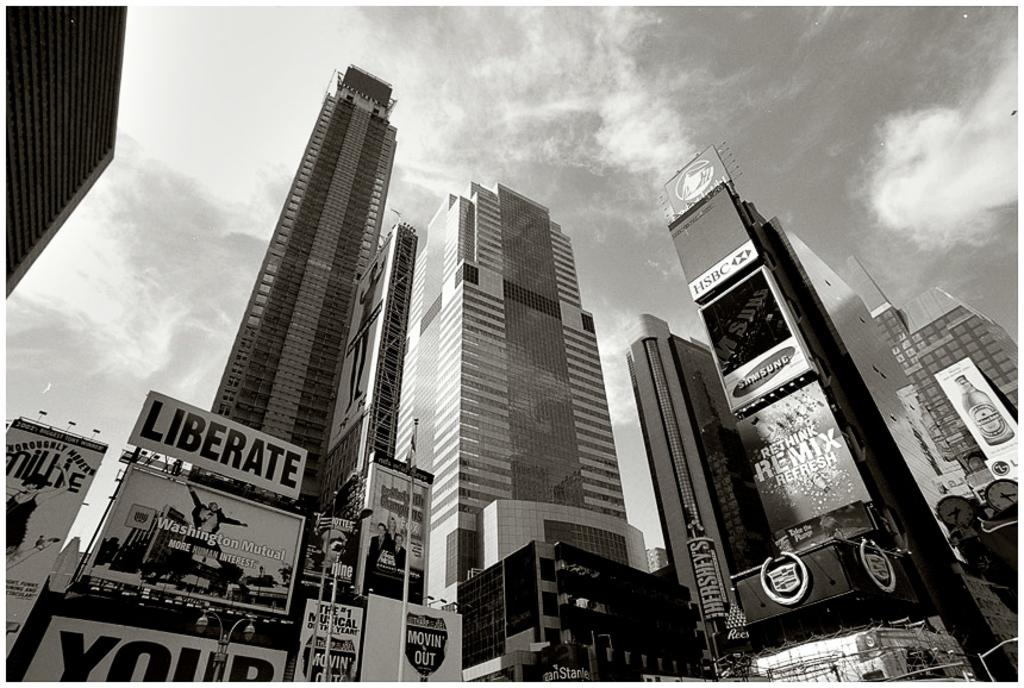What type of structures can be seen in the image? There are buildings and skyscrapers in the image. What else is present in the image besides the buildings? There are boards visible in the image. What is visible in the sky at the top of the image? There are clouds in the sky at the top of the image. Can you tell me how many boats are docked near the buildings in the image? There are no boats present in the image; it features buildings, skyscrapers, and boards. What type of request is being made by the box in the image? There is no box present in the image, and therefore no such request can be observed. 